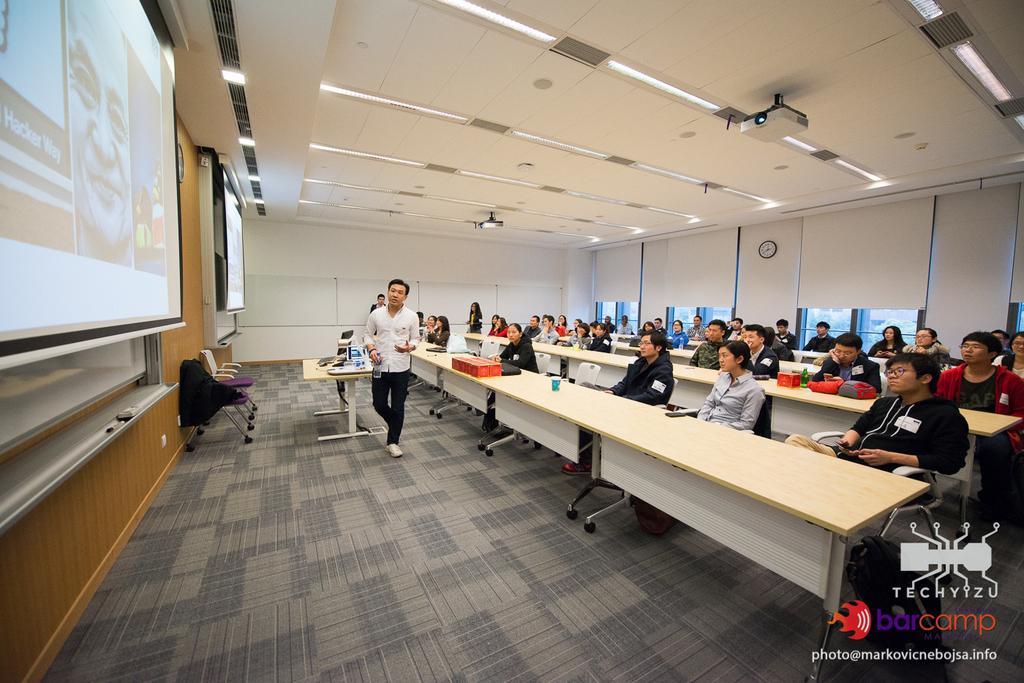How would you summarize this image in a sentence or two? Few people are sitting,this man walking and holding a bottle and few people are standing. We can see bags,glass,bottle and objects on tables and we can see chairs. On the left side of the image we can see screens and wall. In the background we can see clock on a wall and windows. At the top we can see lights. 